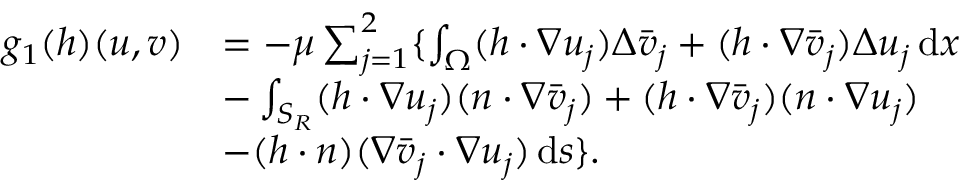<formula> <loc_0><loc_0><loc_500><loc_500>\begin{array} { r l } { g _ { 1 } ( h ) ( u , v ) } & { = - \mu \sum _ { j = 1 } ^ { 2 } \{ \int _ { \Omega } ( h \cdot \nabla u _ { j } ) \Delta \bar { v } _ { j } + ( h \cdot \nabla \bar { v } _ { j } ) \Delta { u } _ { j } \, d x } \\ & { - \int _ { S _ { R } } ( h \cdot \nabla u _ { j } ) ( n \cdot \nabla \bar { v } _ { j } ) + ( h \cdot \nabla \bar { v } _ { j } ) ( n \cdot \nabla { u } _ { j } ) } \\ & { - ( h \cdot n ) ( \nabla \bar { v } _ { j } \cdot \nabla u _ { j } ) \, d s \} . } \end{array}</formula> 